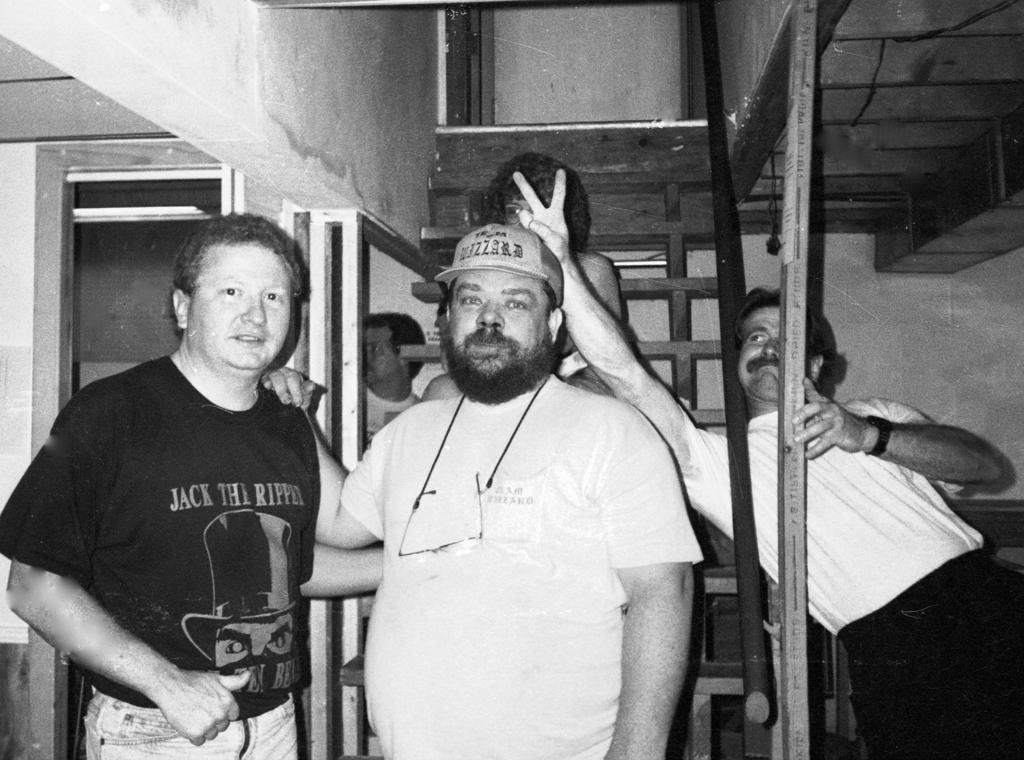How many people are in the image? There are persons in the image, but the exact number is not specified. What are the persons wearing? The persons are wearing clothes. What can be seen in the middle of the image? There is a staircase in the middle of the image. How many rings can be seen on the staircase in the image? There are no rings visible on the staircase in the image. What type of view can be seen from the top of the staircase in the image? The image does not provide any information about a view from the top of the staircase. 